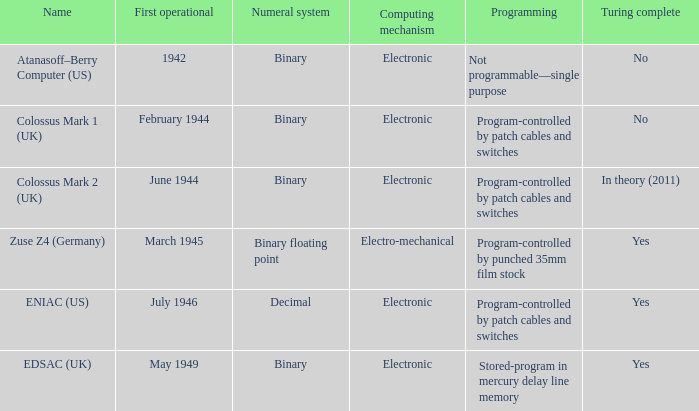What is the computing mechanism called atanasoff-berry computer (us)? Electronic. 